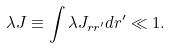Convert formula to latex. <formula><loc_0><loc_0><loc_500><loc_500>\lambda J \equiv \int \lambda J _ { r r ^ { \prime } } d r ^ { \prime } \ll 1 .</formula> 